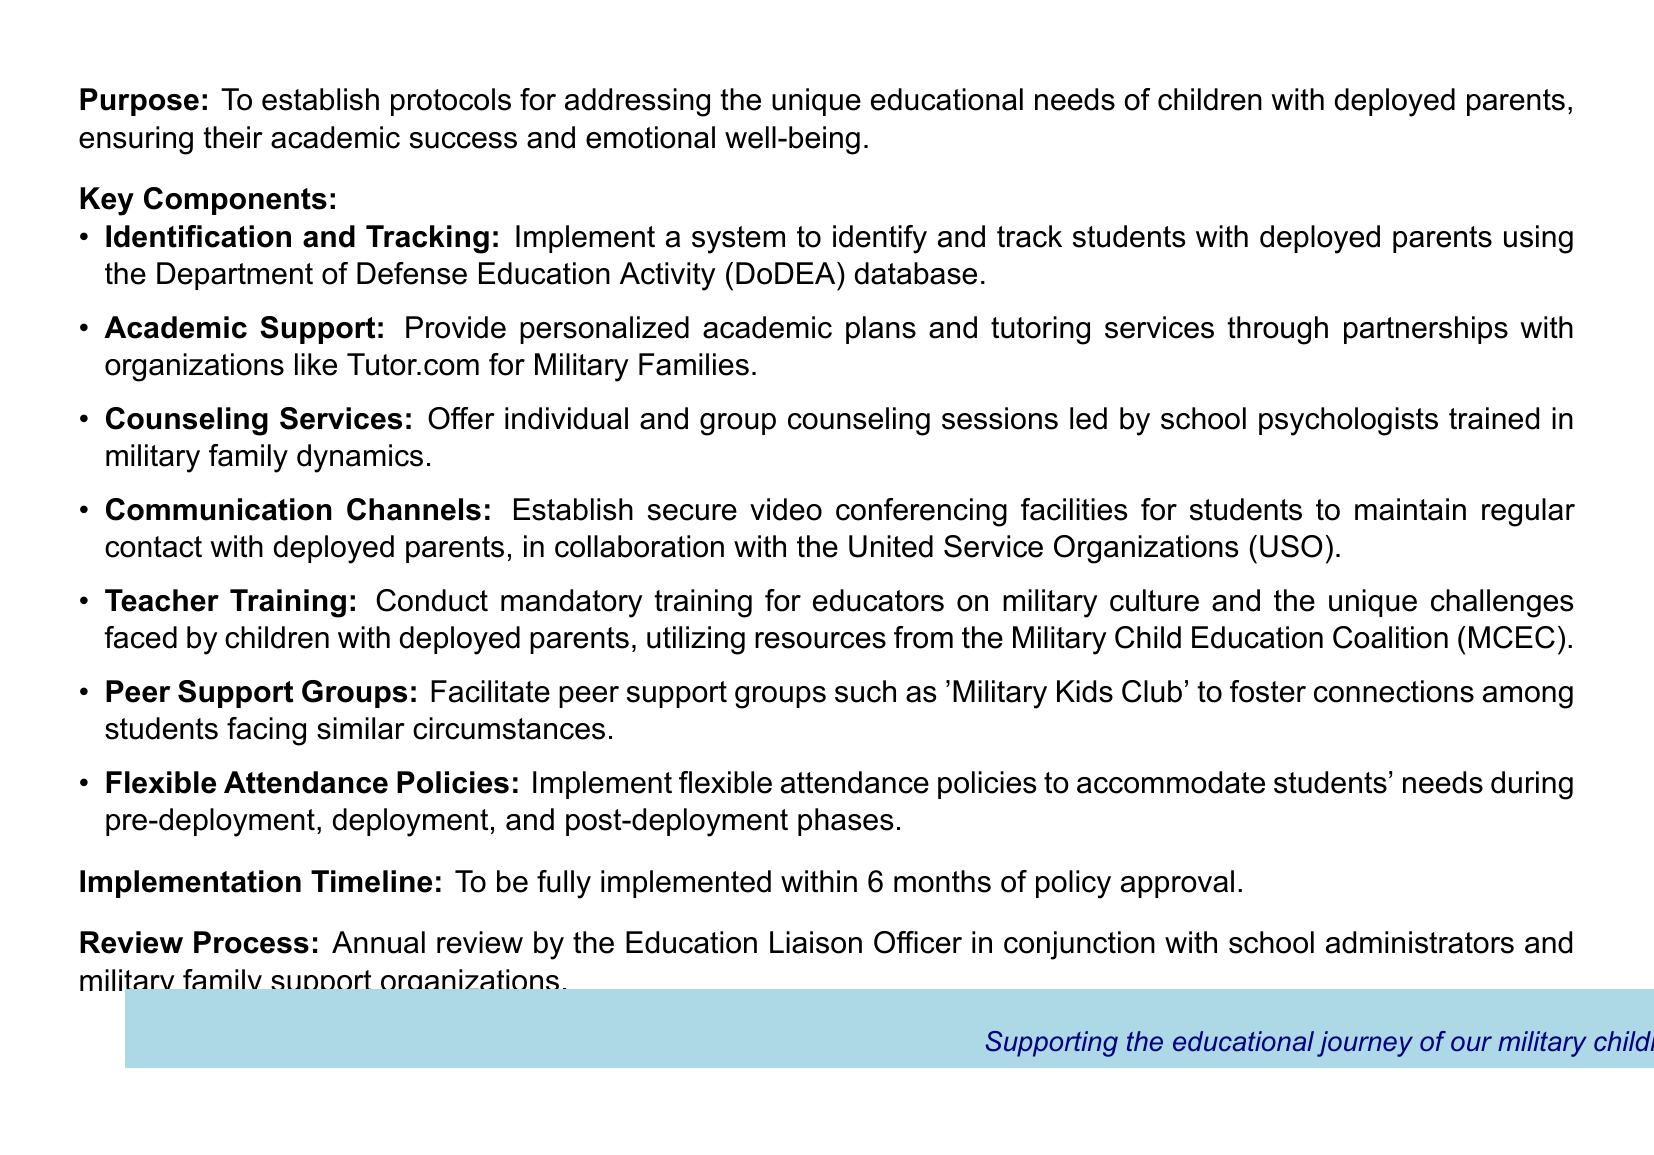What is the purpose of the document? The purpose is to establish protocols for addressing the unique educational needs of children with deployed parents, ensuring their academic success and emotional well-being.
Answer: To establish protocols for addressing the unique educational needs of children with deployed parents, ensuring their academic success and emotional well-being What is the implementation timeline? The document states the timeline for full implementation after policy approval.
Answer: 6 months Who provides academic support for military children? The document mentions partnerships with specific organizations for academic support.
Answer: Tutor.com for Military Families What training is required for educators? The document specifies the training content that educators must receive regarding military families.
Answer: Mandatory training on military culture and the unique challenges faced by children with deployed parents What type of counseling services are offered? The document outlines the type of counseling services available in the schools.
Answer: Individual and group counseling sessions led by school psychologists What is included in the key components of the document? The question seeks to identify the overall themes covered in the key components section.
Answer: Identification and Tracking, Academic Support, Counseling Services, Communication Channels, Teacher Training, Peer Support Groups, Flexible Attendance Policies Who conducts the annual review? The document explains who is responsible for the annual review process.
Answer: Education Liaison Officer What is the aim of peer support groups mentioned in the document? The document describes the purpose of these groups in relation to students' experiences.
Answer: To foster connections among students facing similar circumstances What is the color scheme used in the document? The question pertains to the design elements specified in the document.
Answer: Navy blue and light blue 